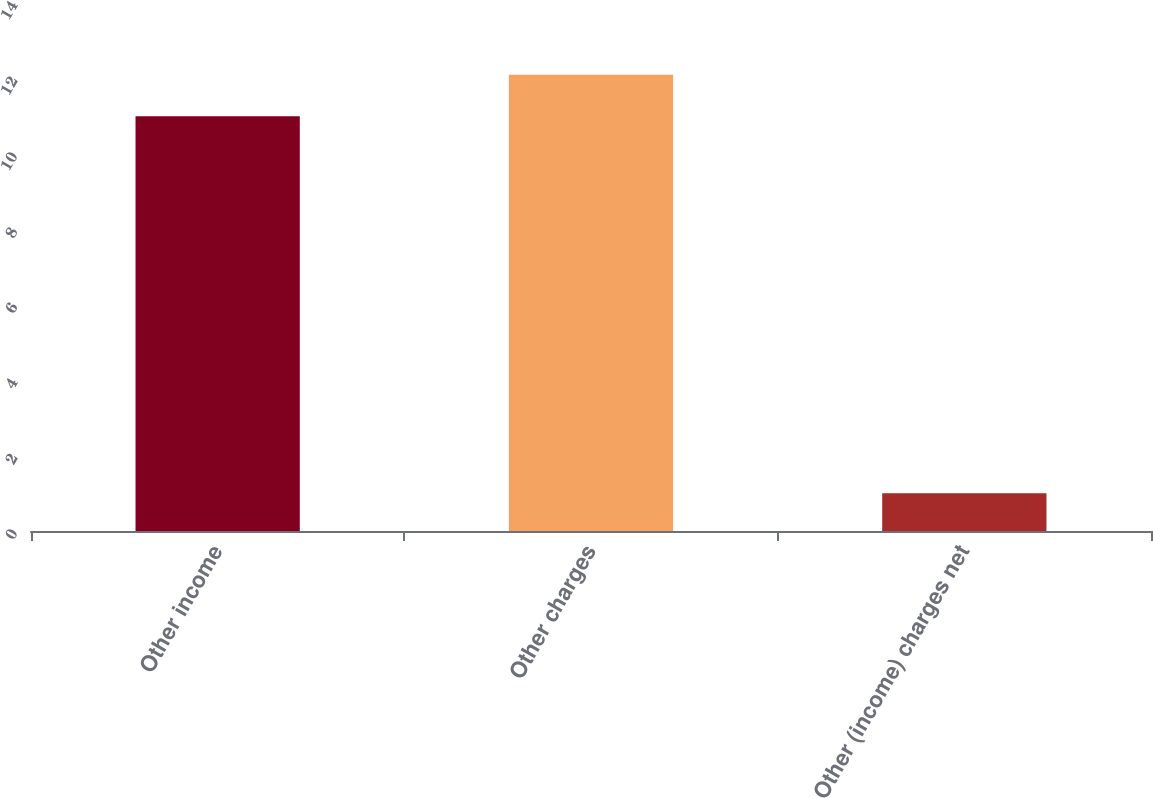Convert chart to OTSL. <chart><loc_0><loc_0><loc_500><loc_500><bar_chart><fcel>Other income<fcel>Other charges<fcel>Other (income) charges net<nl><fcel>11<fcel>12.1<fcel>1<nl></chart> 